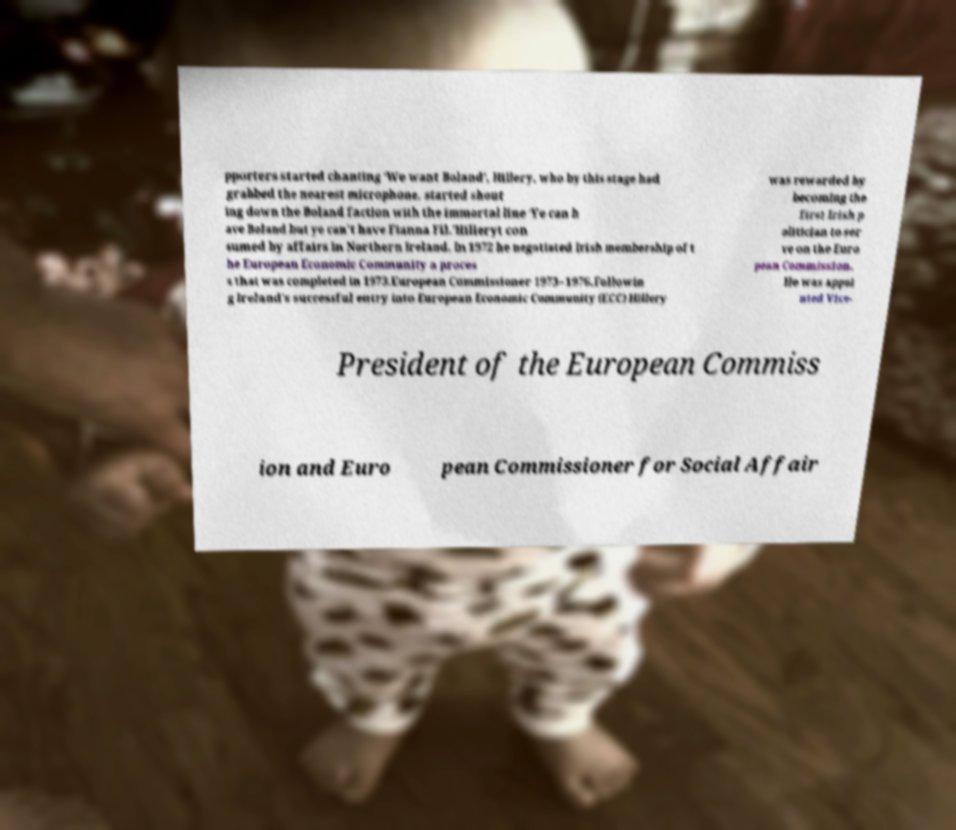What messages or text are displayed in this image? I need them in a readable, typed format. pporters started chanting ‘We want Boland’, Hillery, who by this stage had grabbed the nearest microphone, started shout ing down the Boland faction with the immortal line ‘Ye can h ave Boland but ye can't have Fianna Fil.’Hilleryt con sumed by affairs in Northern Ireland. In 1972 he negotiated Irish membership of t he European Economic Community a proces s that was completed in 1973.European Commissioner 1973–1976.Followin g Ireland's successful entry into European Economic Community (ECC) Hillery was rewarded by becoming the first Irish p olitician to ser ve on the Euro pean Commission. He was appoi nted Vice- President of the European Commiss ion and Euro pean Commissioner for Social Affair 